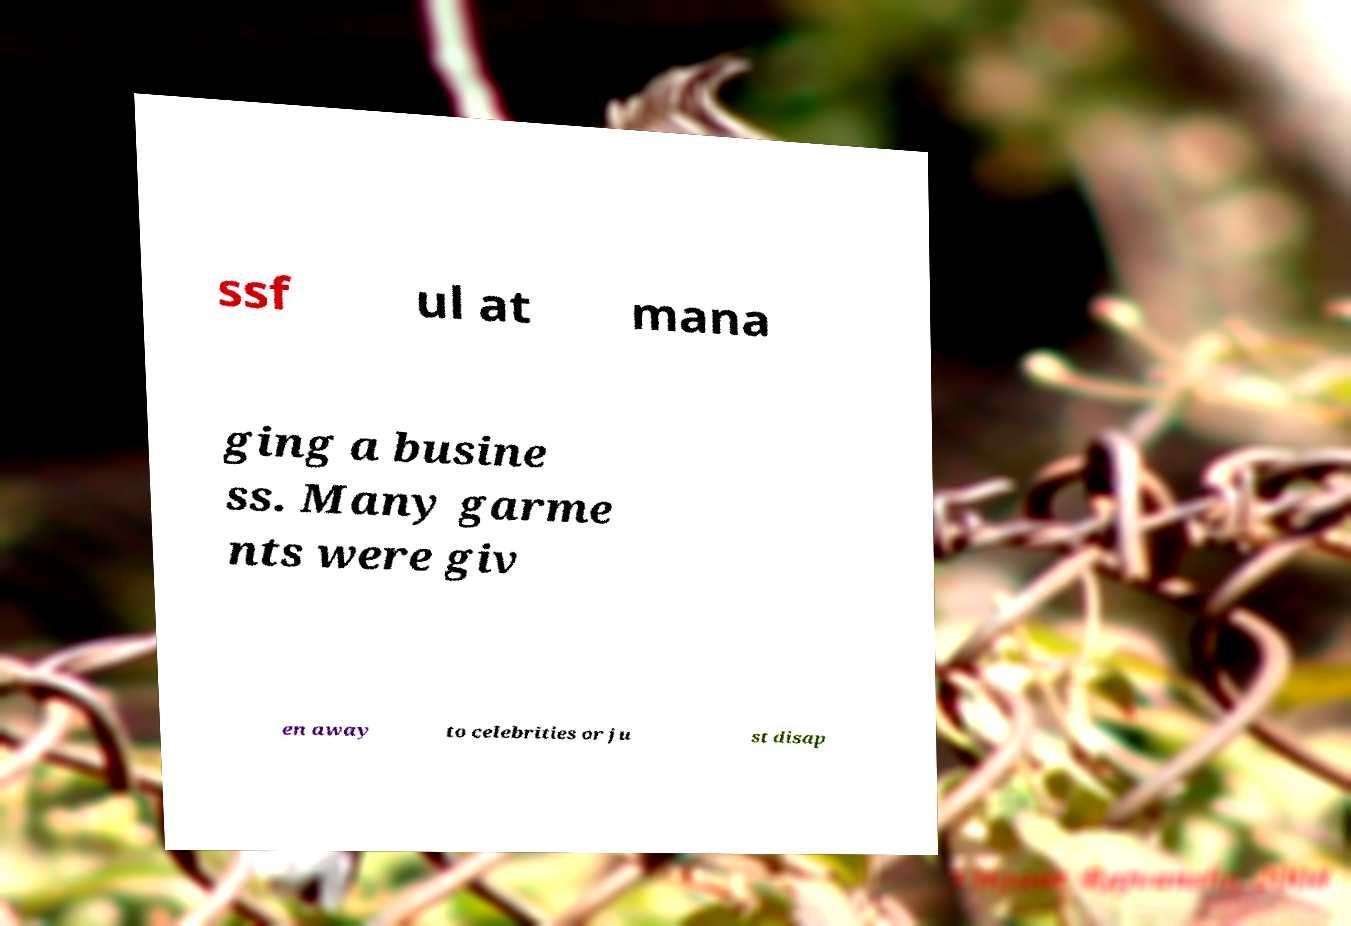Could you extract and type out the text from this image? ssf ul at mana ging a busine ss. Many garme nts were giv en away to celebrities or ju st disap 